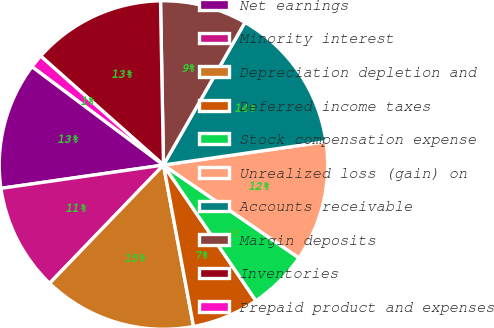Convert chart. <chart><loc_0><loc_0><loc_500><loc_500><pie_chart><fcel>Net earnings<fcel>Minority interest<fcel>Depreciation depletion and<fcel>Deferred income taxes<fcel>Stock compensation expense<fcel>Unrealized loss (gain) on<fcel>Accounts receivable<fcel>Margin deposits<fcel>Inventories<fcel>Prepaid product and expenses<nl><fcel>12.5%<fcel>10.53%<fcel>15.13%<fcel>6.58%<fcel>5.92%<fcel>11.84%<fcel>14.47%<fcel>8.55%<fcel>13.16%<fcel>1.32%<nl></chart> 